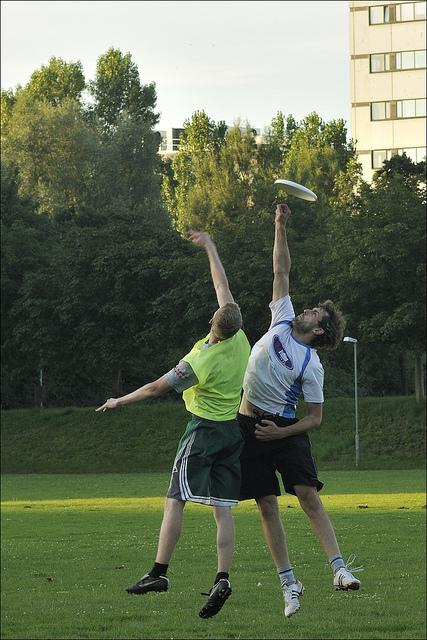What allows this toy to fly?

Choices:
A) lift
B) fan
C) string
D) battery lift 